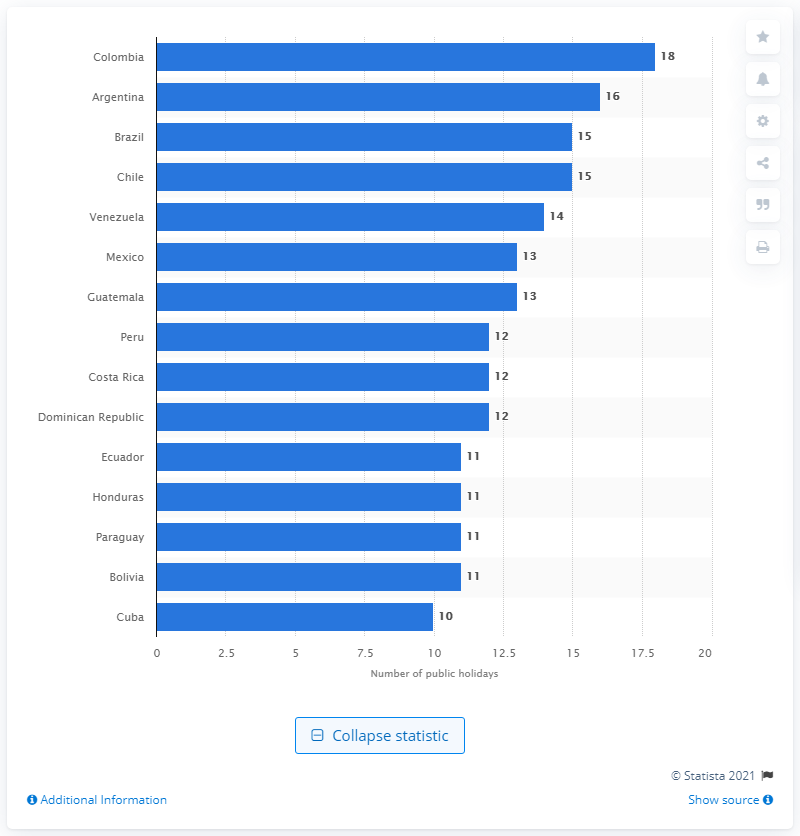Identify some key points in this picture. In 2021, Argentinians are expected to celebrate 16 public holidays. Brazil is the country in Latin America that offers the most paid leave days as a benefit to its employees. 